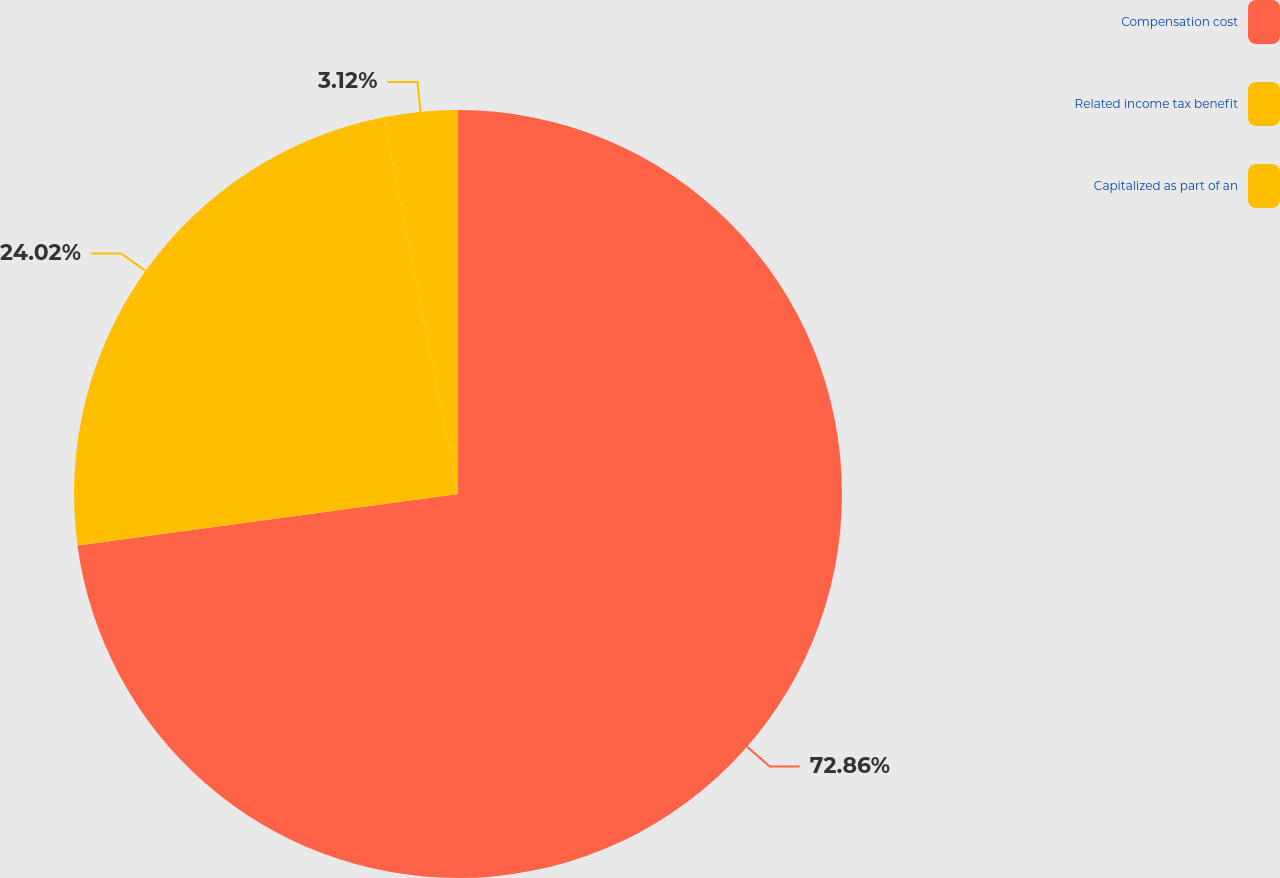Convert chart to OTSL. <chart><loc_0><loc_0><loc_500><loc_500><pie_chart><fcel>Compensation cost<fcel>Related income tax benefit<fcel>Capitalized as part of an<nl><fcel>72.86%<fcel>24.02%<fcel>3.12%<nl></chart> 